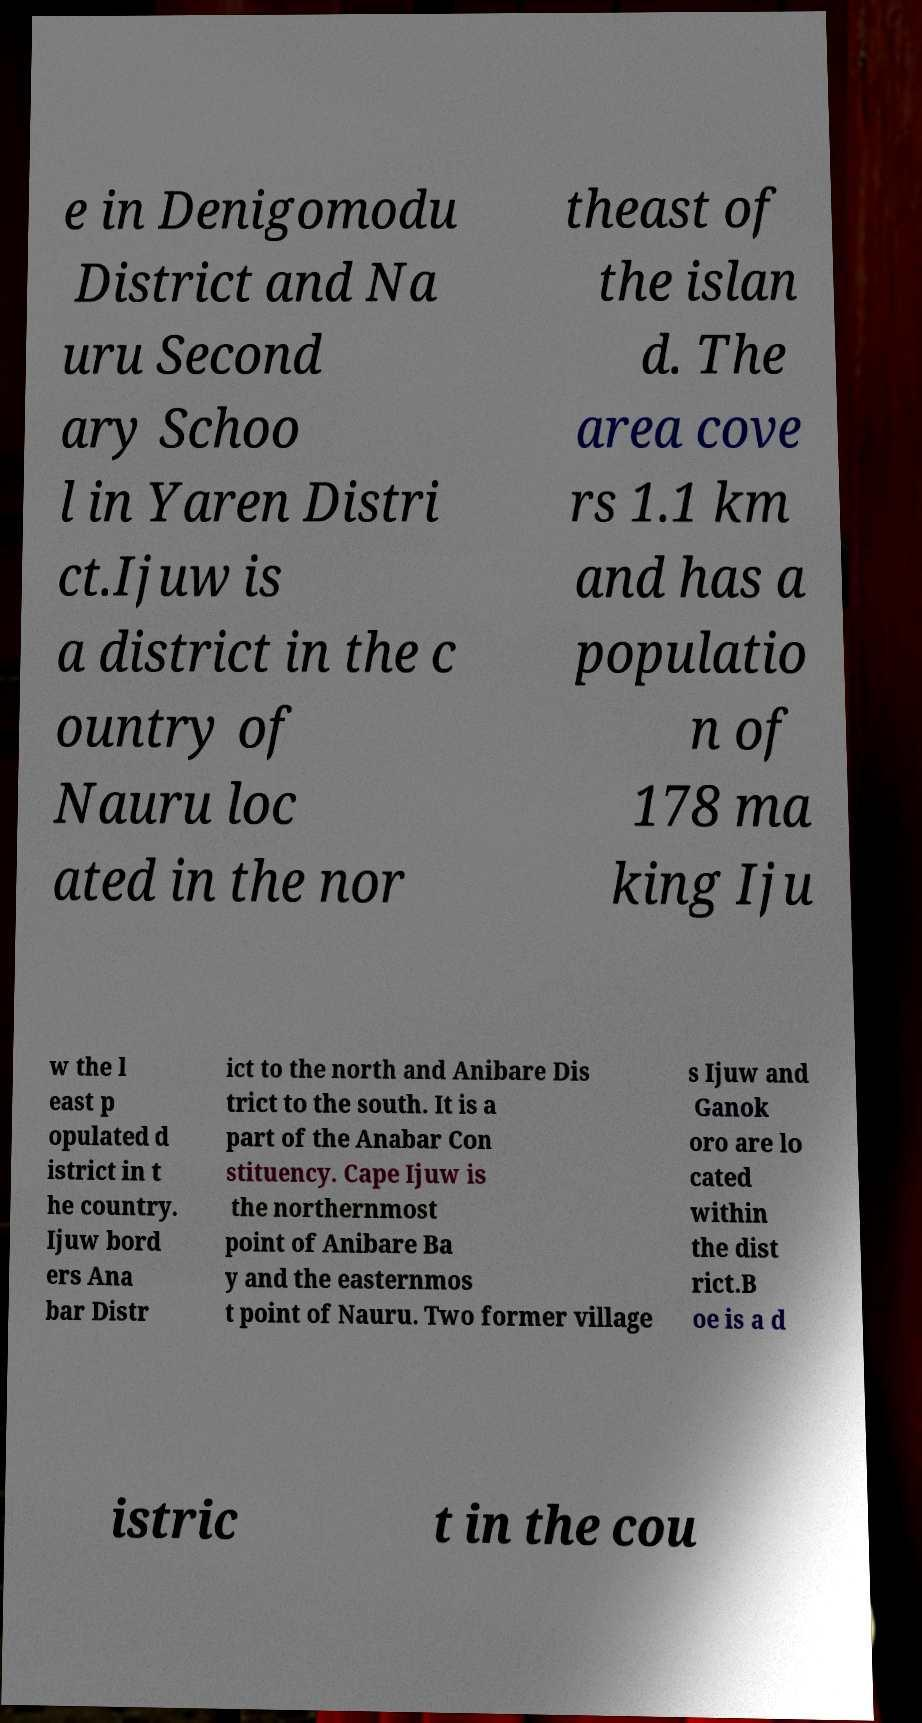What messages or text are displayed in this image? I need them in a readable, typed format. e in Denigomodu District and Na uru Second ary Schoo l in Yaren Distri ct.Ijuw is a district in the c ountry of Nauru loc ated in the nor theast of the islan d. The area cove rs 1.1 km and has a populatio n of 178 ma king Iju w the l east p opulated d istrict in t he country. Ijuw bord ers Ana bar Distr ict to the north and Anibare Dis trict to the south. It is a part of the Anabar Con stituency. Cape Ijuw is the northernmost point of Anibare Ba y and the easternmos t point of Nauru. Two former village s Ijuw and Ganok oro are lo cated within the dist rict.B oe is a d istric t in the cou 